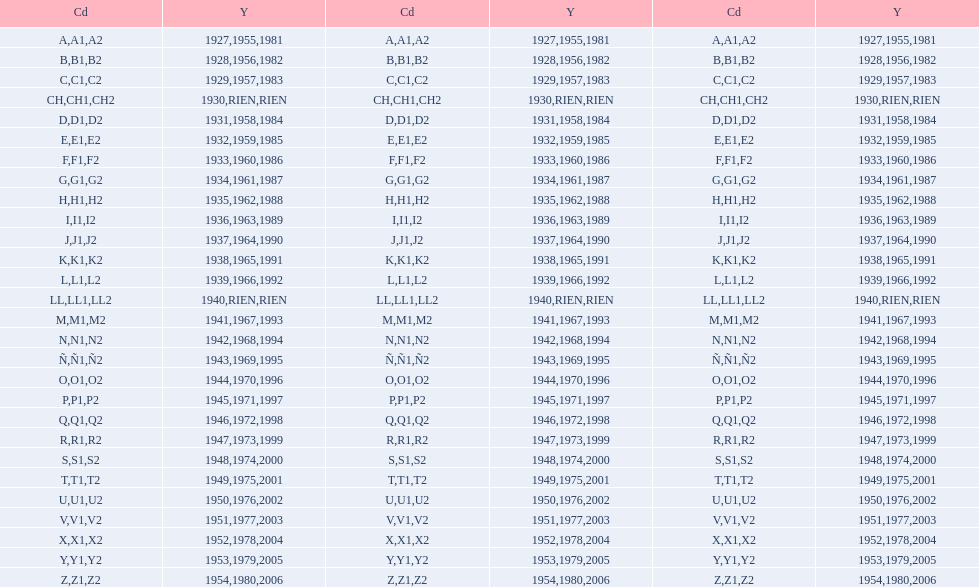What was the only year to use the code ch? 1930. Help me parse the entirety of this table. {'header': ['Cd', 'Y', 'Cd', 'Y', 'Cd', 'Y'], 'rows': [['A', '1927', 'A1', '1955', 'A2', '1981'], ['B', '1928', 'B1', '1956', 'B2', '1982'], ['C', '1929', 'C1', '1957', 'C2', '1983'], ['CH', '1930', 'CH1', 'RIEN', 'CH2', 'RIEN'], ['D', '1931', 'D1', '1958', 'D2', '1984'], ['E', '1932', 'E1', '1959', 'E2', '1985'], ['F', '1933', 'F1', '1960', 'F2', '1986'], ['G', '1934', 'G1', '1961', 'G2', '1987'], ['H', '1935', 'H1', '1962', 'H2', '1988'], ['I', '1936', 'I1', '1963', 'I2', '1989'], ['J', '1937', 'J1', '1964', 'J2', '1990'], ['K', '1938', 'K1', '1965', 'K2', '1991'], ['L', '1939', 'L1', '1966', 'L2', '1992'], ['LL', '1940', 'LL1', 'RIEN', 'LL2', 'RIEN'], ['M', '1941', 'M1', '1967', 'M2', '1993'], ['N', '1942', 'N1', '1968', 'N2', '1994'], ['Ñ', '1943', 'Ñ1', '1969', 'Ñ2', '1995'], ['O', '1944', 'O1', '1970', 'O2', '1996'], ['P', '1945', 'P1', '1971', 'P2', '1997'], ['Q', '1946', 'Q1', '1972', 'Q2', '1998'], ['R', '1947', 'R1', '1973', 'R2', '1999'], ['S', '1948', 'S1', '1974', 'S2', '2000'], ['T', '1949', 'T1', '1975', 'T2', '2001'], ['U', '1950', 'U1', '1976', 'U2', '2002'], ['V', '1951', 'V1', '1977', 'V2', '2003'], ['X', '1952', 'X1', '1978', 'X2', '2004'], ['Y', '1953', 'Y1', '1979', 'Y2', '2005'], ['Z', '1954', 'Z1', '1980', 'Z2', '2006']]} 